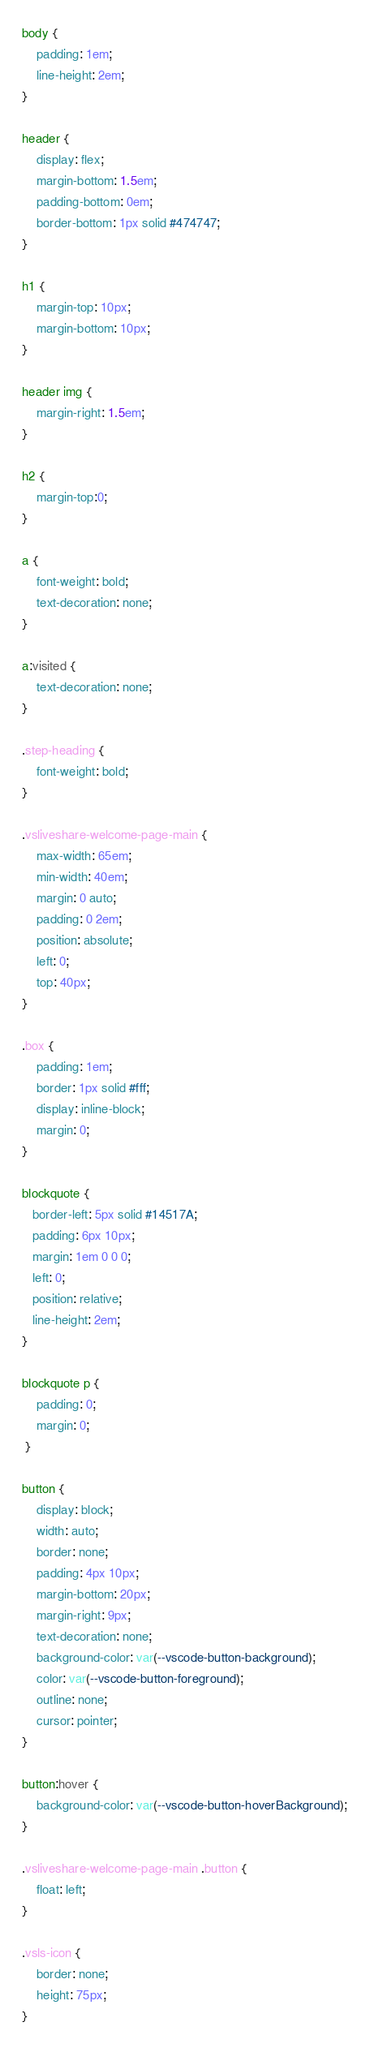<code> <loc_0><loc_0><loc_500><loc_500><_CSS_>body {
    padding: 1em;
    line-height: 2em;
}

header {
    display: flex;
    margin-bottom: 1.5em;
    padding-bottom: 0em;
    border-bottom: 1px solid #474747;
}

h1 {
    margin-top: 10px;
    margin-bottom: 10px;
}

header img {
    margin-right: 1.5em;
}

h2 {
    margin-top:0;
}

a {
    font-weight: bold;
    text-decoration: none;
}

a:visited {
    text-decoration: none;
}

.step-heading {
    font-weight: bold;
}

.vsliveshare-welcome-page-main {
    max-width: 65em;
    min-width: 40em;
    margin: 0 auto;
    padding: 0 2em;
    position: absolute;
    left: 0;
    top: 40px;
}

.box {
    padding: 1em;
    border: 1px solid #fff;
    display: inline-block;
    margin: 0;
}

blockquote {
   border-left: 5px solid #14517A;
   padding: 6px 10px;
   margin: 1em 0 0 0;
   left: 0;
   position: relative;
   line-height: 2em;
}

blockquote p {
    padding: 0;
    margin: 0;
 }

button {
    display: block;
    width: auto;
    border: none;
    padding: 4px 10px;
    margin-bottom: 20px;
    margin-right: 9px;
    text-decoration: none;
    background-color: var(--vscode-button-background);
    color: var(--vscode-button-foreground);
    outline: none;
    cursor: pointer;
}

button:hover {
    background-color: var(--vscode-button-hoverBackground);
}

.vsliveshare-welcome-page-main .button {
    float: left;
}

.vsls-icon {
    border: none;
    height: 75px;
}</code> 